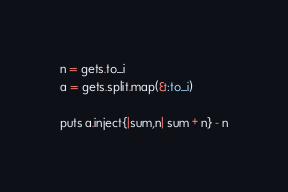<code> <loc_0><loc_0><loc_500><loc_500><_Ruby_>n = gets.to_i
a = gets.split.map(&:to_i)

puts a.inject{|sum,n| sum + n} - n</code> 